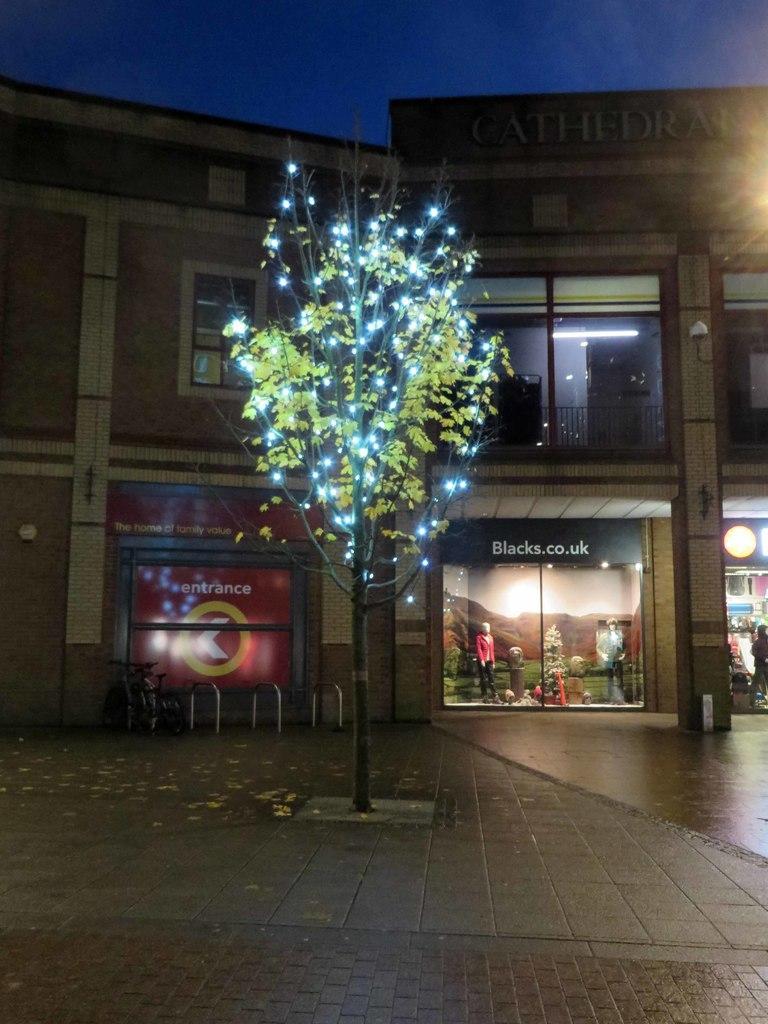How would you summarize this image in a sentence or two? In this picture we can see a tree with lights and in the background we can see a building,person,mannequins,sky. 